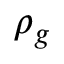<formula> <loc_0><loc_0><loc_500><loc_500>\rho _ { g }</formula> 